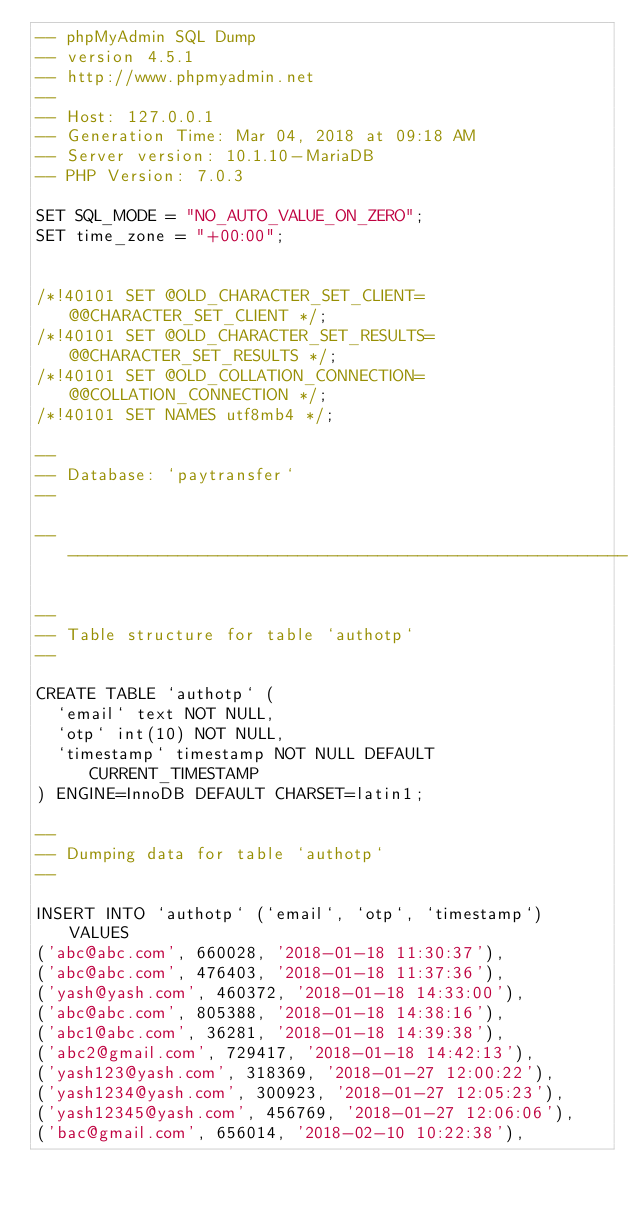<code> <loc_0><loc_0><loc_500><loc_500><_SQL_>-- phpMyAdmin SQL Dump
-- version 4.5.1
-- http://www.phpmyadmin.net
--
-- Host: 127.0.0.1
-- Generation Time: Mar 04, 2018 at 09:18 AM
-- Server version: 10.1.10-MariaDB
-- PHP Version: 7.0.3

SET SQL_MODE = "NO_AUTO_VALUE_ON_ZERO";
SET time_zone = "+00:00";


/*!40101 SET @OLD_CHARACTER_SET_CLIENT=@@CHARACTER_SET_CLIENT */;
/*!40101 SET @OLD_CHARACTER_SET_RESULTS=@@CHARACTER_SET_RESULTS */;
/*!40101 SET @OLD_COLLATION_CONNECTION=@@COLLATION_CONNECTION */;
/*!40101 SET NAMES utf8mb4 */;

--
-- Database: `paytransfer`
--

-- --------------------------------------------------------

--
-- Table structure for table `authotp`
--

CREATE TABLE `authotp` (
  `email` text NOT NULL,
  `otp` int(10) NOT NULL,
  `timestamp` timestamp NOT NULL DEFAULT CURRENT_TIMESTAMP
) ENGINE=InnoDB DEFAULT CHARSET=latin1;

--
-- Dumping data for table `authotp`
--

INSERT INTO `authotp` (`email`, `otp`, `timestamp`) VALUES
('abc@abc.com', 660028, '2018-01-18 11:30:37'),
('abc@abc.com', 476403, '2018-01-18 11:37:36'),
('yash@yash.com', 460372, '2018-01-18 14:33:00'),
('abc@abc.com', 805388, '2018-01-18 14:38:16'),
('abc1@abc.com', 36281, '2018-01-18 14:39:38'),
('abc2@gmail.com', 729417, '2018-01-18 14:42:13'),
('yash123@yash.com', 318369, '2018-01-27 12:00:22'),
('yash1234@yash.com', 300923, '2018-01-27 12:05:23'),
('yash12345@yash.com', 456769, '2018-01-27 12:06:06'),
('bac@gmail.com', 656014, '2018-02-10 10:22:38'),</code> 